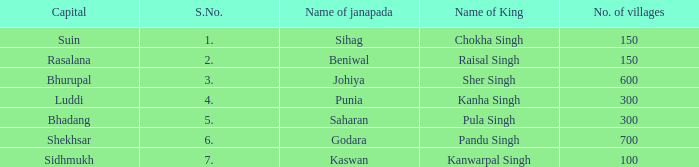What is the average number of villages with a name of janapada of Punia? 300.0. 